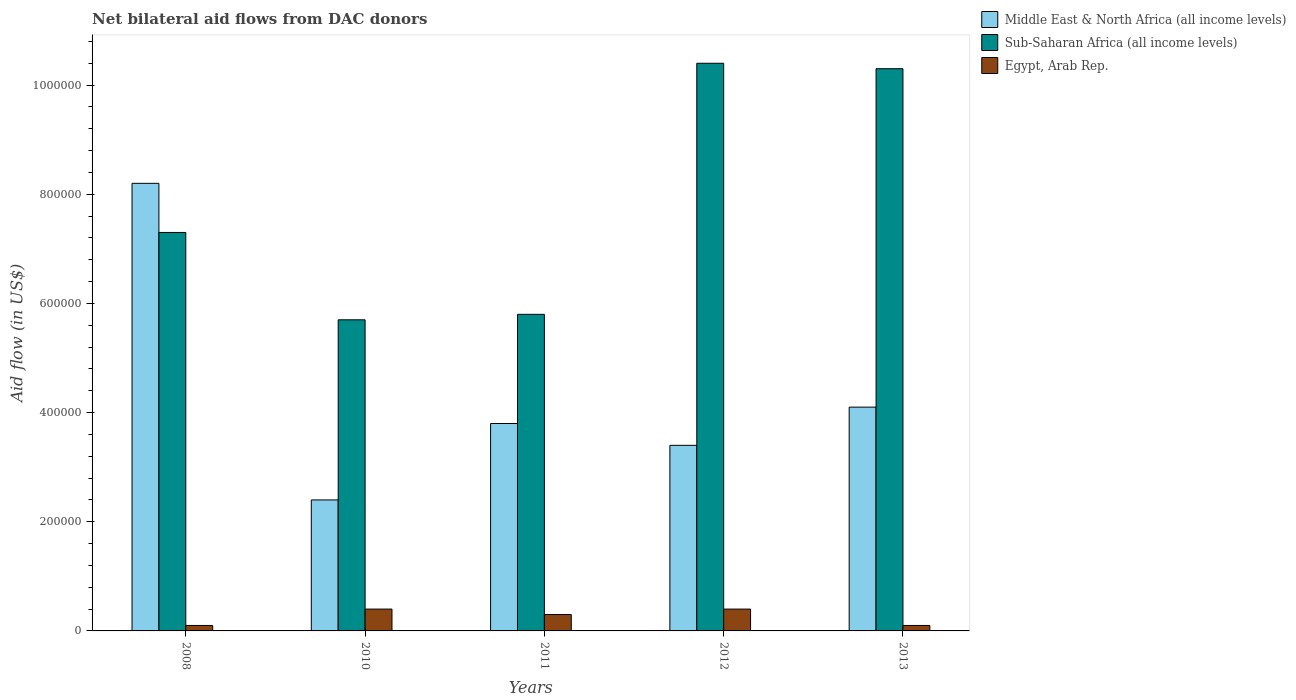How many different coloured bars are there?
Keep it short and to the point. 3. Are the number of bars per tick equal to the number of legend labels?
Provide a short and direct response. Yes. Are the number of bars on each tick of the X-axis equal?
Your response must be concise. Yes. How many bars are there on the 4th tick from the left?
Offer a very short reply. 3. How many bars are there on the 2nd tick from the right?
Keep it short and to the point. 3. In how many cases, is the number of bars for a given year not equal to the number of legend labels?
Provide a succinct answer. 0. What is the net bilateral aid flow in Sub-Saharan Africa (all income levels) in 2013?
Make the answer very short. 1.03e+06. Across all years, what is the maximum net bilateral aid flow in Middle East & North Africa (all income levels)?
Offer a terse response. 8.20e+05. What is the difference between the net bilateral aid flow in Egypt, Arab Rep. in 2008 and that in 2012?
Provide a succinct answer. -3.00e+04. What is the difference between the net bilateral aid flow in Sub-Saharan Africa (all income levels) in 2008 and the net bilateral aid flow in Middle East & North Africa (all income levels) in 2012?
Provide a short and direct response. 3.90e+05. What is the average net bilateral aid flow in Egypt, Arab Rep. per year?
Offer a terse response. 2.60e+04. In the year 2010, what is the difference between the net bilateral aid flow in Sub-Saharan Africa (all income levels) and net bilateral aid flow in Middle East & North Africa (all income levels)?
Give a very brief answer. 3.30e+05. In how many years, is the net bilateral aid flow in Sub-Saharan Africa (all income levels) greater than 680000 US$?
Provide a short and direct response. 3. What is the ratio of the net bilateral aid flow in Sub-Saharan Africa (all income levels) in 2008 to that in 2012?
Your answer should be very brief. 0.7. What is the difference between the highest and the lowest net bilateral aid flow in Middle East & North Africa (all income levels)?
Your answer should be very brief. 5.80e+05. What does the 3rd bar from the left in 2008 represents?
Give a very brief answer. Egypt, Arab Rep. What does the 1st bar from the right in 2011 represents?
Your response must be concise. Egypt, Arab Rep. Is it the case that in every year, the sum of the net bilateral aid flow in Middle East & North Africa (all income levels) and net bilateral aid flow in Sub-Saharan Africa (all income levels) is greater than the net bilateral aid flow in Egypt, Arab Rep.?
Your answer should be very brief. Yes. Are all the bars in the graph horizontal?
Provide a short and direct response. No. How many years are there in the graph?
Give a very brief answer. 5. What is the difference between two consecutive major ticks on the Y-axis?
Offer a very short reply. 2.00e+05. Are the values on the major ticks of Y-axis written in scientific E-notation?
Your answer should be compact. No. Does the graph contain any zero values?
Offer a terse response. No. Does the graph contain grids?
Provide a succinct answer. No. What is the title of the graph?
Provide a short and direct response. Net bilateral aid flows from DAC donors. Does "Algeria" appear as one of the legend labels in the graph?
Offer a very short reply. No. What is the label or title of the X-axis?
Keep it short and to the point. Years. What is the label or title of the Y-axis?
Offer a very short reply. Aid flow (in US$). What is the Aid flow (in US$) in Middle East & North Africa (all income levels) in 2008?
Your response must be concise. 8.20e+05. What is the Aid flow (in US$) in Sub-Saharan Africa (all income levels) in 2008?
Keep it short and to the point. 7.30e+05. What is the Aid flow (in US$) in Sub-Saharan Africa (all income levels) in 2010?
Your answer should be very brief. 5.70e+05. What is the Aid flow (in US$) in Middle East & North Africa (all income levels) in 2011?
Your answer should be very brief. 3.80e+05. What is the Aid flow (in US$) in Sub-Saharan Africa (all income levels) in 2011?
Your answer should be compact. 5.80e+05. What is the Aid flow (in US$) of Egypt, Arab Rep. in 2011?
Provide a short and direct response. 3.00e+04. What is the Aid flow (in US$) of Middle East & North Africa (all income levels) in 2012?
Your answer should be compact. 3.40e+05. What is the Aid flow (in US$) of Sub-Saharan Africa (all income levels) in 2012?
Offer a terse response. 1.04e+06. What is the Aid flow (in US$) in Sub-Saharan Africa (all income levels) in 2013?
Give a very brief answer. 1.03e+06. What is the Aid flow (in US$) of Egypt, Arab Rep. in 2013?
Your response must be concise. 10000. Across all years, what is the maximum Aid flow (in US$) of Middle East & North Africa (all income levels)?
Give a very brief answer. 8.20e+05. Across all years, what is the maximum Aid flow (in US$) in Sub-Saharan Africa (all income levels)?
Keep it short and to the point. 1.04e+06. Across all years, what is the maximum Aid flow (in US$) in Egypt, Arab Rep.?
Keep it short and to the point. 4.00e+04. Across all years, what is the minimum Aid flow (in US$) in Middle East & North Africa (all income levels)?
Make the answer very short. 2.40e+05. Across all years, what is the minimum Aid flow (in US$) in Sub-Saharan Africa (all income levels)?
Offer a terse response. 5.70e+05. What is the total Aid flow (in US$) of Middle East & North Africa (all income levels) in the graph?
Make the answer very short. 2.19e+06. What is the total Aid flow (in US$) of Sub-Saharan Africa (all income levels) in the graph?
Ensure brevity in your answer.  3.95e+06. What is the total Aid flow (in US$) of Egypt, Arab Rep. in the graph?
Offer a terse response. 1.30e+05. What is the difference between the Aid flow (in US$) in Middle East & North Africa (all income levels) in 2008 and that in 2010?
Keep it short and to the point. 5.80e+05. What is the difference between the Aid flow (in US$) in Sub-Saharan Africa (all income levels) in 2008 and that in 2010?
Provide a short and direct response. 1.60e+05. What is the difference between the Aid flow (in US$) in Middle East & North Africa (all income levels) in 2008 and that in 2011?
Your answer should be compact. 4.40e+05. What is the difference between the Aid flow (in US$) of Sub-Saharan Africa (all income levels) in 2008 and that in 2011?
Ensure brevity in your answer.  1.50e+05. What is the difference between the Aid flow (in US$) of Middle East & North Africa (all income levels) in 2008 and that in 2012?
Offer a terse response. 4.80e+05. What is the difference between the Aid flow (in US$) in Sub-Saharan Africa (all income levels) in 2008 and that in 2012?
Keep it short and to the point. -3.10e+05. What is the difference between the Aid flow (in US$) of Middle East & North Africa (all income levels) in 2008 and that in 2013?
Your answer should be very brief. 4.10e+05. What is the difference between the Aid flow (in US$) of Egypt, Arab Rep. in 2008 and that in 2013?
Offer a very short reply. 0. What is the difference between the Aid flow (in US$) of Sub-Saharan Africa (all income levels) in 2010 and that in 2011?
Provide a succinct answer. -10000. What is the difference between the Aid flow (in US$) of Middle East & North Africa (all income levels) in 2010 and that in 2012?
Give a very brief answer. -1.00e+05. What is the difference between the Aid flow (in US$) of Sub-Saharan Africa (all income levels) in 2010 and that in 2012?
Keep it short and to the point. -4.70e+05. What is the difference between the Aid flow (in US$) of Egypt, Arab Rep. in 2010 and that in 2012?
Offer a terse response. 0. What is the difference between the Aid flow (in US$) in Middle East & North Africa (all income levels) in 2010 and that in 2013?
Make the answer very short. -1.70e+05. What is the difference between the Aid flow (in US$) of Sub-Saharan Africa (all income levels) in 2010 and that in 2013?
Your answer should be compact. -4.60e+05. What is the difference between the Aid flow (in US$) of Egypt, Arab Rep. in 2010 and that in 2013?
Your response must be concise. 3.00e+04. What is the difference between the Aid flow (in US$) of Sub-Saharan Africa (all income levels) in 2011 and that in 2012?
Your answer should be compact. -4.60e+05. What is the difference between the Aid flow (in US$) in Middle East & North Africa (all income levels) in 2011 and that in 2013?
Offer a very short reply. -3.00e+04. What is the difference between the Aid flow (in US$) of Sub-Saharan Africa (all income levels) in 2011 and that in 2013?
Offer a very short reply. -4.50e+05. What is the difference between the Aid flow (in US$) of Egypt, Arab Rep. in 2011 and that in 2013?
Offer a very short reply. 2.00e+04. What is the difference between the Aid flow (in US$) in Middle East & North Africa (all income levels) in 2008 and the Aid flow (in US$) in Egypt, Arab Rep. in 2010?
Provide a succinct answer. 7.80e+05. What is the difference between the Aid flow (in US$) of Sub-Saharan Africa (all income levels) in 2008 and the Aid flow (in US$) of Egypt, Arab Rep. in 2010?
Provide a short and direct response. 6.90e+05. What is the difference between the Aid flow (in US$) in Middle East & North Africa (all income levels) in 2008 and the Aid flow (in US$) in Sub-Saharan Africa (all income levels) in 2011?
Ensure brevity in your answer.  2.40e+05. What is the difference between the Aid flow (in US$) of Middle East & North Africa (all income levels) in 2008 and the Aid flow (in US$) of Egypt, Arab Rep. in 2011?
Offer a terse response. 7.90e+05. What is the difference between the Aid flow (in US$) of Middle East & North Africa (all income levels) in 2008 and the Aid flow (in US$) of Sub-Saharan Africa (all income levels) in 2012?
Provide a short and direct response. -2.20e+05. What is the difference between the Aid flow (in US$) of Middle East & North Africa (all income levels) in 2008 and the Aid flow (in US$) of Egypt, Arab Rep. in 2012?
Your answer should be compact. 7.80e+05. What is the difference between the Aid flow (in US$) in Sub-Saharan Africa (all income levels) in 2008 and the Aid flow (in US$) in Egypt, Arab Rep. in 2012?
Provide a short and direct response. 6.90e+05. What is the difference between the Aid flow (in US$) in Middle East & North Africa (all income levels) in 2008 and the Aid flow (in US$) in Egypt, Arab Rep. in 2013?
Your answer should be very brief. 8.10e+05. What is the difference between the Aid flow (in US$) in Sub-Saharan Africa (all income levels) in 2008 and the Aid flow (in US$) in Egypt, Arab Rep. in 2013?
Make the answer very short. 7.20e+05. What is the difference between the Aid flow (in US$) in Middle East & North Africa (all income levels) in 2010 and the Aid flow (in US$) in Sub-Saharan Africa (all income levels) in 2011?
Offer a very short reply. -3.40e+05. What is the difference between the Aid flow (in US$) in Sub-Saharan Africa (all income levels) in 2010 and the Aid flow (in US$) in Egypt, Arab Rep. in 2011?
Ensure brevity in your answer.  5.40e+05. What is the difference between the Aid flow (in US$) in Middle East & North Africa (all income levels) in 2010 and the Aid flow (in US$) in Sub-Saharan Africa (all income levels) in 2012?
Offer a terse response. -8.00e+05. What is the difference between the Aid flow (in US$) in Sub-Saharan Africa (all income levels) in 2010 and the Aid flow (in US$) in Egypt, Arab Rep. in 2012?
Offer a terse response. 5.30e+05. What is the difference between the Aid flow (in US$) of Middle East & North Africa (all income levels) in 2010 and the Aid flow (in US$) of Sub-Saharan Africa (all income levels) in 2013?
Offer a terse response. -7.90e+05. What is the difference between the Aid flow (in US$) in Sub-Saharan Africa (all income levels) in 2010 and the Aid flow (in US$) in Egypt, Arab Rep. in 2013?
Make the answer very short. 5.60e+05. What is the difference between the Aid flow (in US$) of Middle East & North Africa (all income levels) in 2011 and the Aid flow (in US$) of Sub-Saharan Africa (all income levels) in 2012?
Make the answer very short. -6.60e+05. What is the difference between the Aid flow (in US$) of Middle East & North Africa (all income levels) in 2011 and the Aid flow (in US$) of Egypt, Arab Rep. in 2012?
Keep it short and to the point. 3.40e+05. What is the difference between the Aid flow (in US$) of Sub-Saharan Africa (all income levels) in 2011 and the Aid flow (in US$) of Egypt, Arab Rep. in 2012?
Make the answer very short. 5.40e+05. What is the difference between the Aid flow (in US$) of Middle East & North Africa (all income levels) in 2011 and the Aid flow (in US$) of Sub-Saharan Africa (all income levels) in 2013?
Offer a terse response. -6.50e+05. What is the difference between the Aid flow (in US$) in Middle East & North Africa (all income levels) in 2011 and the Aid flow (in US$) in Egypt, Arab Rep. in 2013?
Offer a very short reply. 3.70e+05. What is the difference between the Aid flow (in US$) in Sub-Saharan Africa (all income levels) in 2011 and the Aid flow (in US$) in Egypt, Arab Rep. in 2013?
Your response must be concise. 5.70e+05. What is the difference between the Aid flow (in US$) in Middle East & North Africa (all income levels) in 2012 and the Aid flow (in US$) in Sub-Saharan Africa (all income levels) in 2013?
Your response must be concise. -6.90e+05. What is the difference between the Aid flow (in US$) in Sub-Saharan Africa (all income levels) in 2012 and the Aid flow (in US$) in Egypt, Arab Rep. in 2013?
Your response must be concise. 1.03e+06. What is the average Aid flow (in US$) of Middle East & North Africa (all income levels) per year?
Keep it short and to the point. 4.38e+05. What is the average Aid flow (in US$) of Sub-Saharan Africa (all income levels) per year?
Offer a very short reply. 7.90e+05. What is the average Aid flow (in US$) of Egypt, Arab Rep. per year?
Your response must be concise. 2.60e+04. In the year 2008, what is the difference between the Aid flow (in US$) of Middle East & North Africa (all income levels) and Aid flow (in US$) of Egypt, Arab Rep.?
Your answer should be very brief. 8.10e+05. In the year 2008, what is the difference between the Aid flow (in US$) of Sub-Saharan Africa (all income levels) and Aid flow (in US$) of Egypt, Arab Rep.?
Provide a short and direct response. 7.20e+05. In the year 2010, what is the difference between the Aid flow (in US$) of Middle East & North Africa (all income levels) and Aid flow (in US$) of Sub-Saharan Africa (all income levels)?
Your answer should be compact. -3.30e+05. In the year 2010, what is the difference between the Aid flow (in US$) in Sub-Saharan Africa (all income levels) and Aid flow (in US$) in Egypt, Arab Rep.?
Your answer should be very brief. 5.30e+05. In the year 2011, what is the difference between the Aid flow (in US$) of Middle East & North Africa (all income levels) and Aid flow (in US$) of Egypt, Arab Rep.?
Your answer should be very brief. 3.50e+05. In the year 2011, what is the difference between the Aid flow (in US$) in Sub-Saharan Africa (all income levels) and Aid flow (in US$) in Egypt, Arab Rep.?
Offer a very short reply. 5.50e+05. In the year 2012, what is the difference between the Aid flow (in US$) of Middle East & North Africa (all income levels) and Aid flow (in US$) of Sub-Saharan Africa (all income levels)?
Keep it short and to the point. -7.00e+05. In the year 2012, what is the difference between the Aid flow (in US$) in Sub-Saharan Africa (all income levels) and Aid flow (in US$) in Egypt, Arab Rep.?
Your response must be concise. 1.00e+06. In the year 2013, what is the difference between the Aid flow (in US$) of Middle East & North Africa (all income levels) and Aid flow (in US$) of Sub-Saharan Africa (all income levels)?
Offer a very short reply. -6.20e+05. In the year 2013, what is the difference between the Aid flow (in US$) of Sub-Saharan Africa (all income levels) and Aid flow (in US$) of Egypt, Arab Rep.?
Your answer should be compact. 1.02e+06. What is the ratio of the Aid flow (in US$) in Middle East & North Africa (all income levels) in 2008 to that in 2010?
Provide a succinct answer. 3.42. What is the ratio of the Aid flow (in US$) of Sub-Saharan Africa (all income levels) in 2008 to that in 2010?
Ensure brevity in your answer.  1.28. What is the ratio of the Aid flow (in US$) in Egypt, Arab Rep. in 2008 to that in 2010?
Make the answer very short. 0.25. What is the ratio of the Aid flow (in US$) in Middle East & North Africa (all income levels) in 2008 to that in 2011?
Your answer should be compact. 2.16. What is the ratio of the Aid flow (in US$) of Sub-Saharan Africa (all income levels) in 2008 to that in 2011?
Give a very brief answer. 1.26. What is the ratio of the Aid flow (in US$) in Middle East & North Africa (all income levels) in 2008 to that in 2012?
Provide a short and direct response. 2.41. What is the ratio of the Aid flow (in US$) of Sub-Saharan Africa (all income levels) in 2008 to that in 2012?
Your response must be concise. 0.7. What is the ratio of the Aid flow (in US$) in Egypt, Arab Rep. in 2008 to that in 2012?
Offer a terse response. 0.25. What is the ratio of the Aid flow (in US$) in Sub-Saharan Africa (all income levels) in 2008 to that in 2013?
Offer a very short reply. 0.71. What is the ratio of the Aid flow (in US$) in Middle East & North Africa (all income levels) in 2010 to that in 2011?
Ensure brevity in your answer.  0.63. What is the ratio of the Aid flow (in US$) in Sub-Saharan Africa (all income levels) in 2010 to that in 2011?
Make the answer very short. 0.98. What is the ratio of the Aid flow (in US$) in Egypt, Arab Rep. in 2010 to that in 2011?
Provide a short and direct response. 1.33. What is the ratio of the Aid flow (in US$) of Middle East & North Africa (all income levels) in 2010 to that in 2012?
Offer a terse response. 0.71. What is the ratio of the Aid flow (in US$) of Sub-Saharan Africa (all income levels) in 2010 to that in 2012?
Keep it short and to the point. 0.55. What is the ratio of the Aid flow (in US$) in Middle East & North Africa (all income levels) in 2010 to that in 2013?
Offer a terse response. 0.59. What is the ratio of the Aid flow (in US$) in Sub-Saharan Africa (all income levels) in 2010 to that in 2013?
Provide a succinct answer. 0.55. What is the ratio of the Aid flow (in US$) in Egypt, Arab Rep. in 2010 to that in 2013?
Your response must be concise. 4. What is the ratio of the Aid flow (in US$) in Middle East & North Africa (all income levels) in 2011 to that in 2012?
Your response must be concise. 1.12. What is the ratio of the Aid flow (in US$) in Sub-Saharan Africa (all income levels) in 2011 to that in 2012?
Provide a succinct answer. 0.56. What is the ratio of the Aid flow (in US$) of Middle East & North Africa (all income levels) in 2011 to that in 2013?
Your answer should be compact. 0.93. What is the ratio of the Aid flow (in US$) of Sub-Saharan Africa (all income levels) in 2011 to that in 2013?
Provide a short and direct response. 0.56. What is the ratio of the Aid flow (in US$) in Middle East & North Africa (all income levels) in 2012 to that in 2013?
Your answer should be compact. 0.83. What is the ratio of the Aid flow (in US$) in Sub-Saharan Africa (all income levels) in 2012 to that in 2013?
Ensure brevity in your answer.  1.01. What is the difference between the highest and the second highest Aid flow (in US$) in Middle East & North Africa (all income levels)?
Give a very brief answer. 4.10e+05. What is the difference between the highest and the second highest Aid flow (in US$) of Sub-Saharan Africa (all income levels)?
Your answer should be very brief. 10000. What is the difference between the highest and the lowest Aid flow (in US$) of Middle East & North Africa (all income levels)?
Give a very brief answer. 5.80e+05. What is the difference between the highest and the lowest Aid flow (in US$) in Sub-Saharan Africa (all income levels)?
Give a very brief answer. 4.70e+05. 